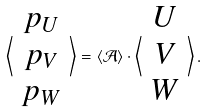Convert formula to latex. <formula><loc_0><loc_0><loc_500><loc_500>\left \langle \begin{array} { c } p _ { U } \\ p _ { V } \\ p _ { W } \end{array} \right \rangle = \langle { \mathcal { A } } \rangle \cdot \left \langle \begin{array} { c } U \\ V \\ W \end{array} \right \rangle .</formula> 